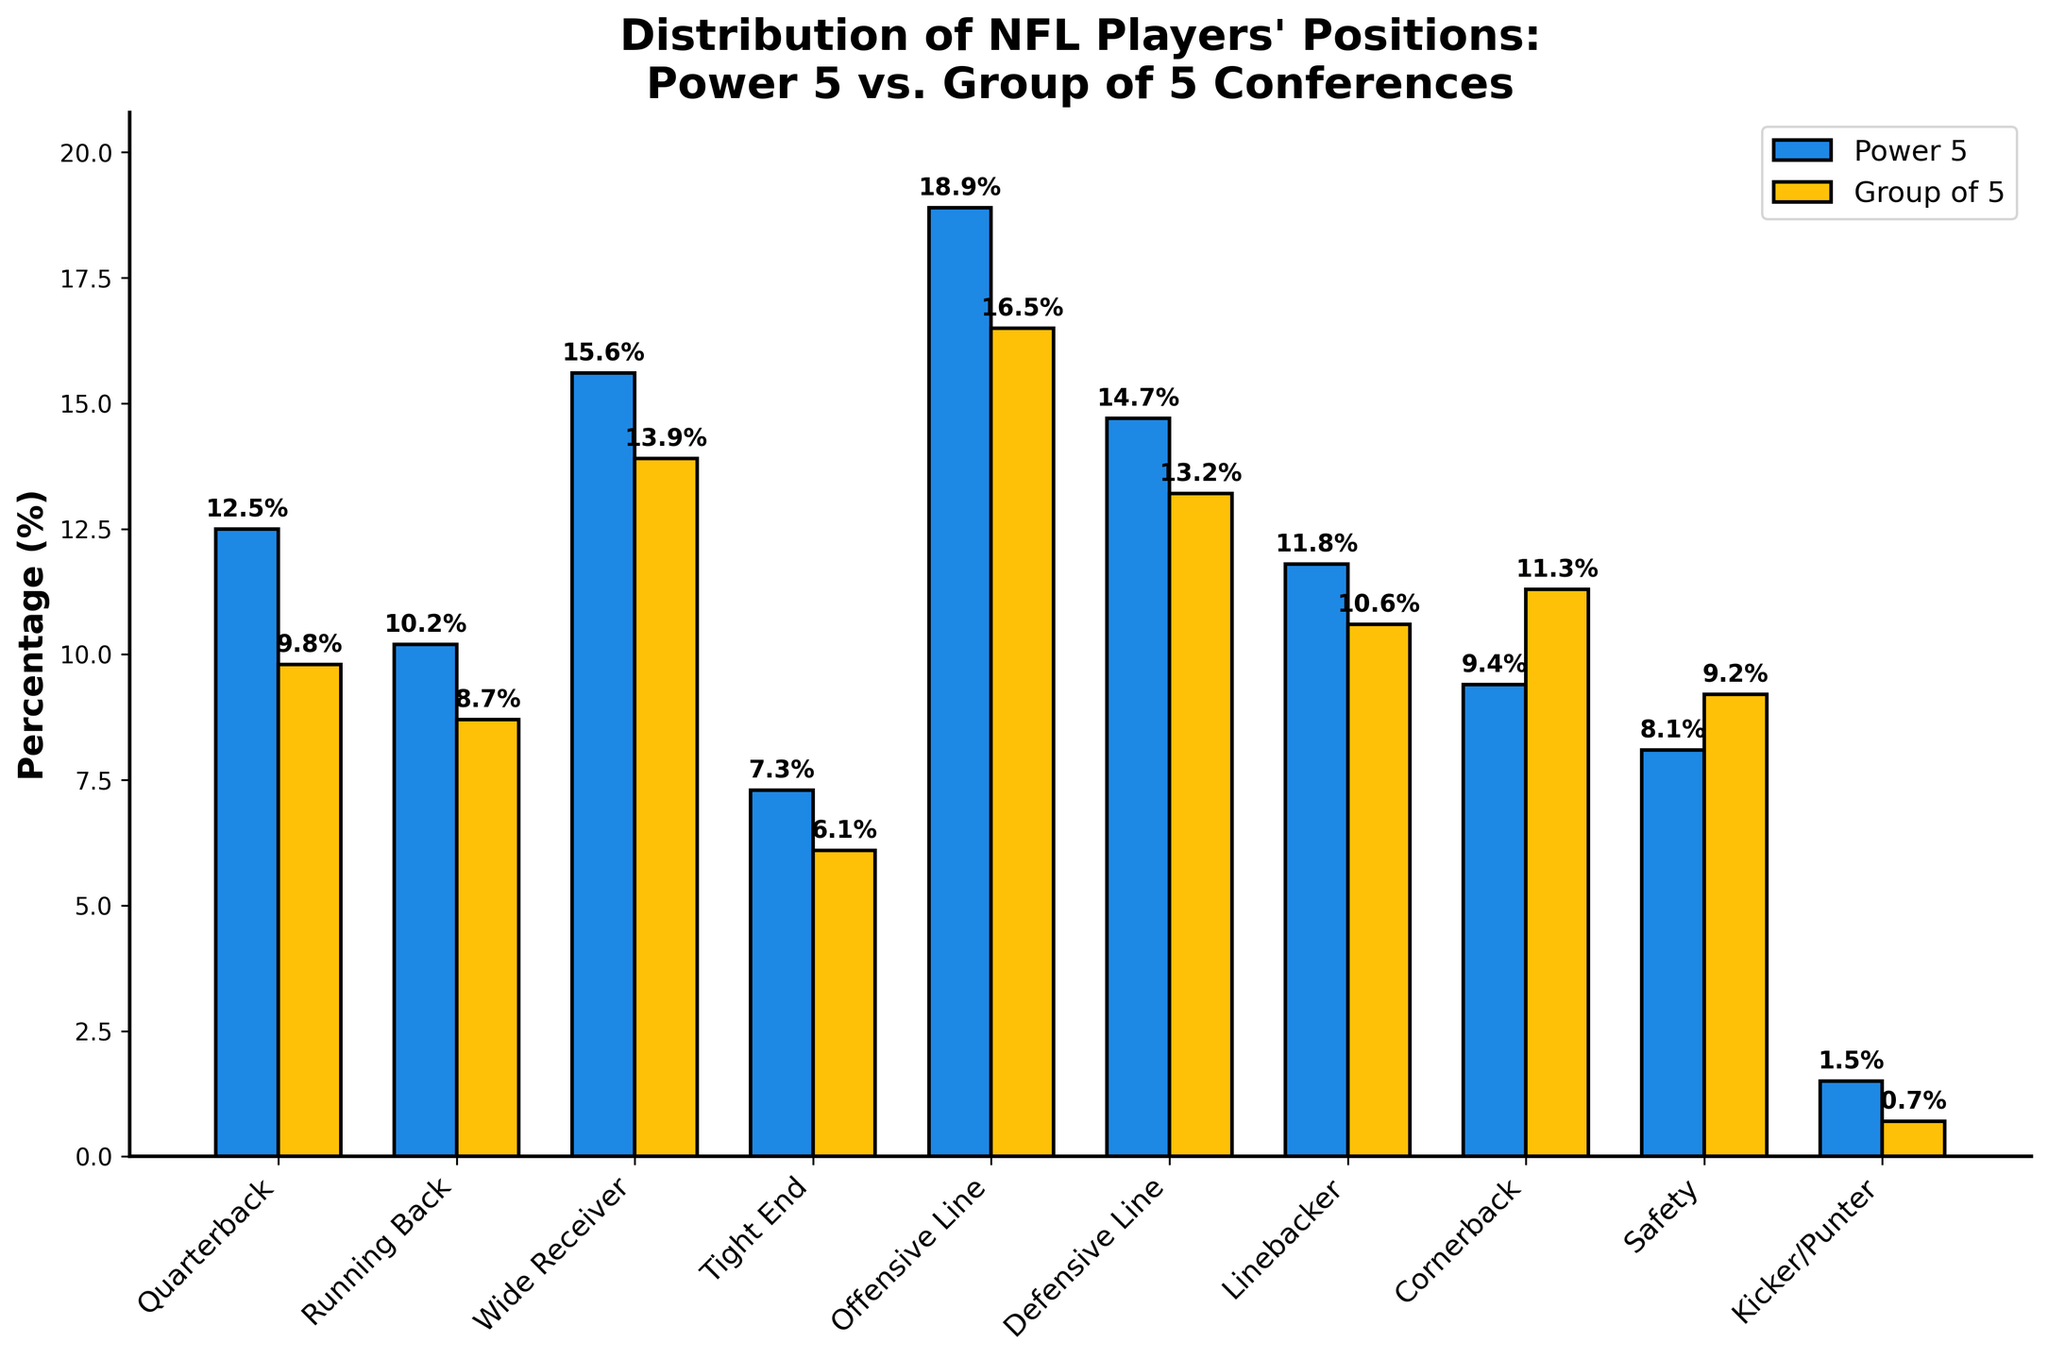Which position has the highest percentage of NFL players from Power 5 conferences? The highest bar in the Power 5 group is for the Offensive Line position.
Answer: Offensive Line Which group has a higher percentage of NFL Wide Receivers? Compare the percentage for Wide Receivers in both groups. The Power 5 has 15.6%, and the Group of 5 has 13.9%.
Answer: Power 5 What is the difference in percentage between Power 5 and Group of 5 for Defensive Line positions? Subtract the Group of 5 percentage (13.2%) from the Power 5 percentage (14.7%). 14.7 - 13.2 = 1.5
Answer: 1.5 Which position has a greater percentage in Group of 5 compared to Power 5? Look for bars in the Group of 5 group that exceed their counterparts in the Power 5 group. The Cornerback and Safety positions have higher percentages in the Group of 5 (11.3% and 9.2%, respectively) compared to Power 5 (9.4% and 8.1%, respectively).
Answer: Cornerback, Safety Which position shows the smallest difference in percentage between Power 5 and Group of 5? Calculate the difference for each position and identify the smallest one. The Tight End position has a difference of 7.3% - 6.1% = 1.2, which is the smallest.
Answer: Tight End What is the total percentage of NFL players from Power 5 conferences in Offensive and Defensive Line positions? Sum the percentages for Offensive Line (18.9%) and Defensive Line (14.7%). 18.9 + 14.7 = 33.6
Answer: 33.6 Based on the visual attributes, which group has shorter bars in general, Power 5 or Group of 5? Observing the bar heights, the Power 5 group generally has taller bars compared to the Group of 5 group.
Answer: Group of 5 Which position has the least representation in the NFL from Group of 5 conferences? Identify the shortest bar in the Group of 5 group, which is for Kicker/Punter at 0.7%.
Answer: Kicker/Punter What is the average percentage of NFL players from the Group of 5 conferences for all positions? Sum the percentages for Group of 5 (9.8 + 8.7 + 13.9 + 6.1 + 16.5 + 13.2 + 10.6 + 11.3 + 9.2 + 0.7 = 100) and divide by the number of positions (10). 100 / 10 = 10
Answer: 10 Which position shows nearly equal representation between Power 5 and Group of 5? Look for bars that are close in height between the two groups. The Defensive Line position has percentages of 14.7% (Power 5) and 13.2% (Group of 5), showing near equality.
Answer: Defensive Line 